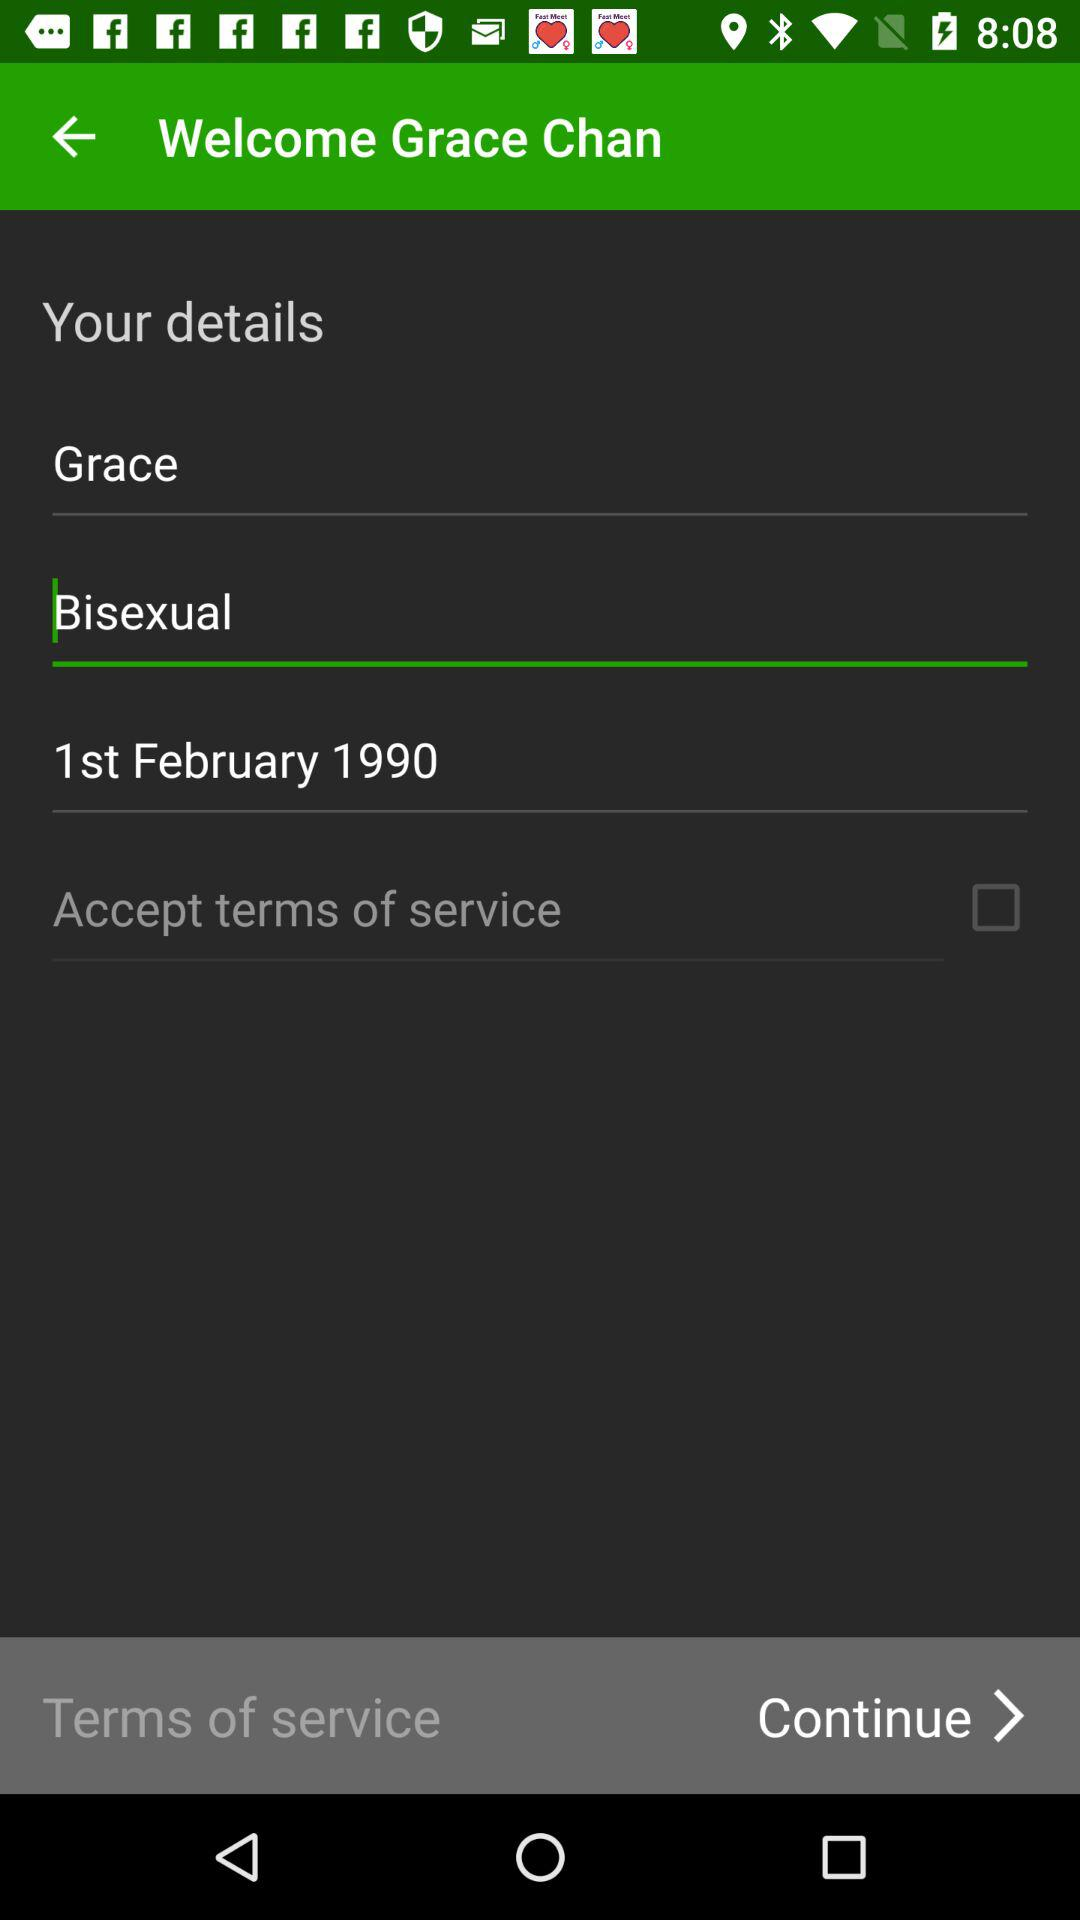What's the status of "Accept terms of service"? The status of "Accept terms of service" is "off". 